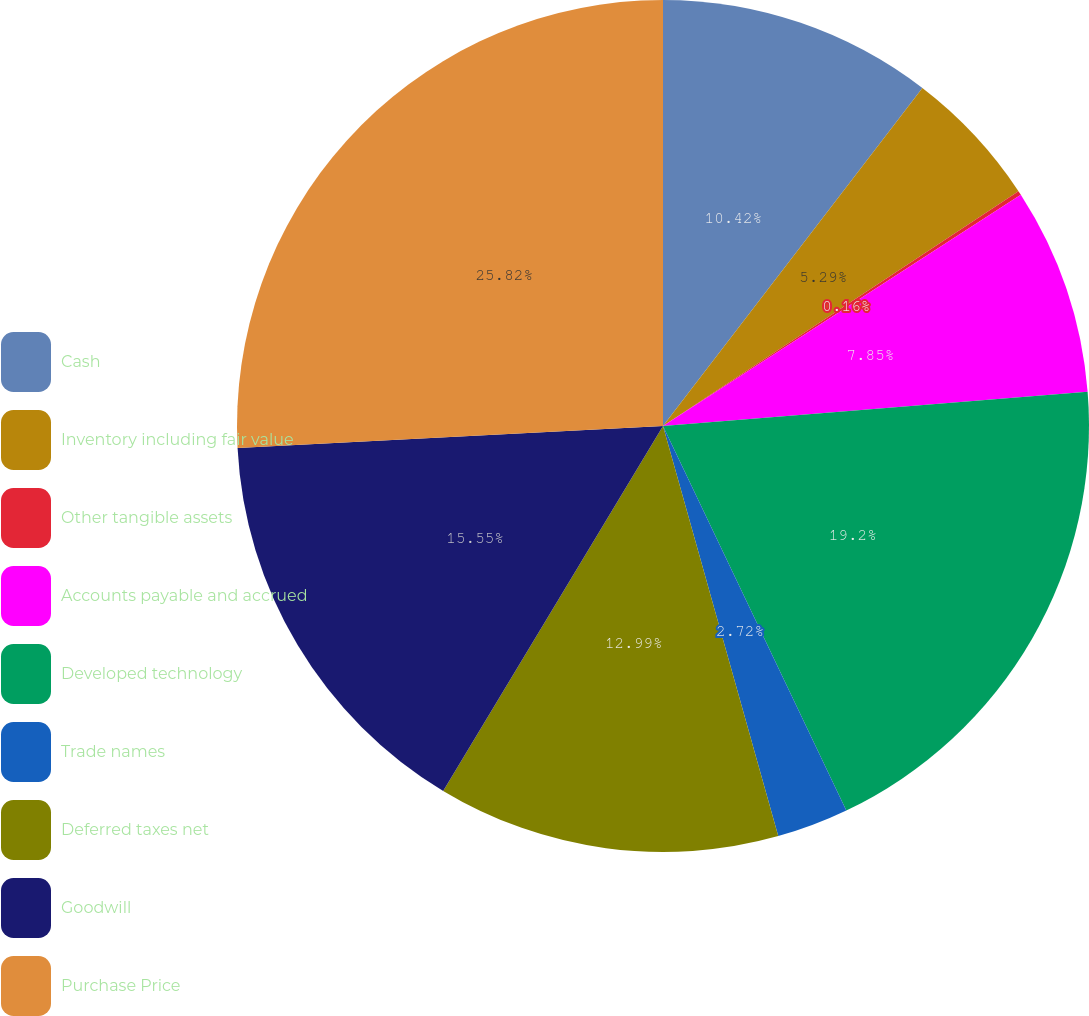Convert chart to OTSL. <chart><loc_0><loc_0><loc_500><loc_500><pie_chart><fcel>Cash<fcel>Inventory including fair value<fcel>Other tangible assets<fcel>Accounts payable and accrued<fcel>Developed technology<fcel>Trade names<fcel>Deferred taxes net<fcel>Goodwill<fcel>Purchase Price<nl><fcel>10.42%<fcel>5.29%<fcel>0.16%<fcel>7.85%<fcel>19.2%<fcel>2.72%<fcel>12.99%<fcel>15.55%<fcel>25.82%<nl></chart> 